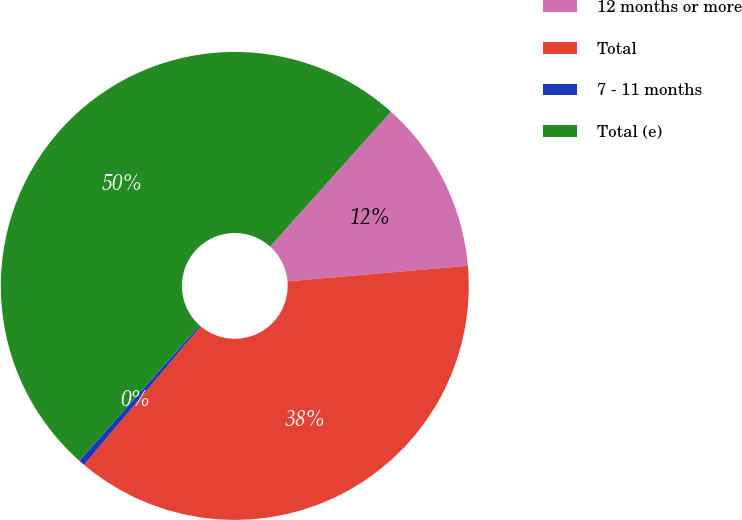Convert chart. <chart><loc_0><loc_0><loc_500><loc_500><pie_chart><fcel>12 months or more<fcel>Total<fcel>7 - 11 months<fcel>Total (e)<nl><fcel>11.99%<fcel>37.51%<fcel>0.43%<fcel>50.06%<nl></chart> 